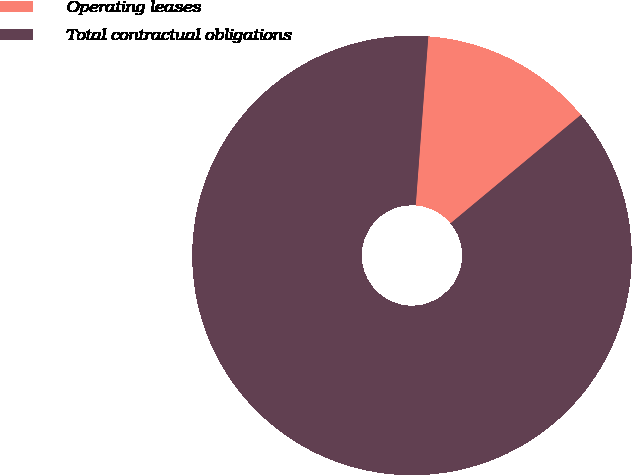Convert chart to OTSL. <chart><loc_0><loc_0><loc_500><loc_500><pie_chart><fcel>Operating leases<fcel>Total contractual obligations<nl><fcel>12.77%<fcel>87.23%<nl></chart> 